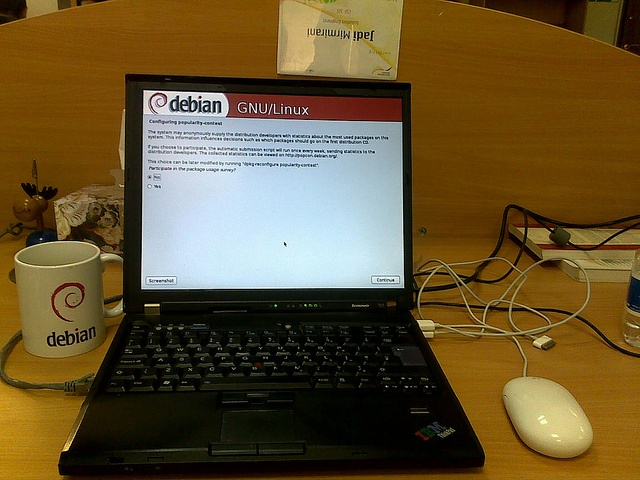Describe the objects in this image and their specific colors. I can see laptop in black, lightblue, and darkgray tones, keyboard in black, gray, and darkgreen tones, cup in black and olive tones, book in black, olive, and tan tones, and mouse in black, tan, khaki, and olive tones in this image. 